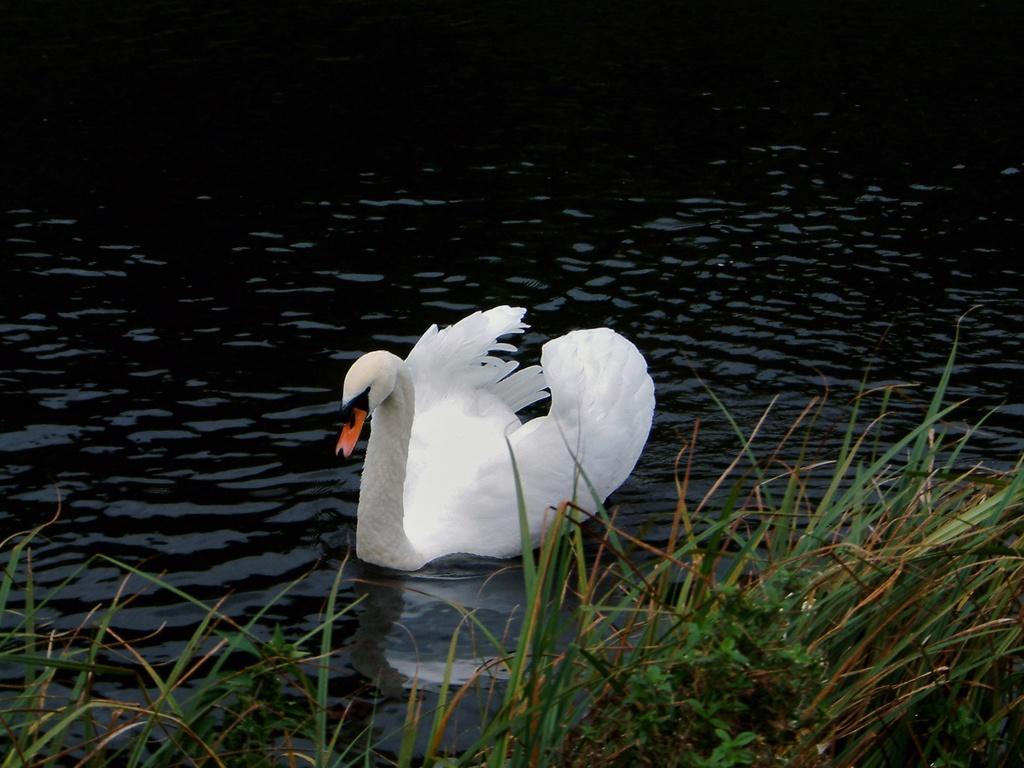Please provide a concise description of this image. In this picture I can see the grass in front and in the background I can see the water on which there is a swan. 